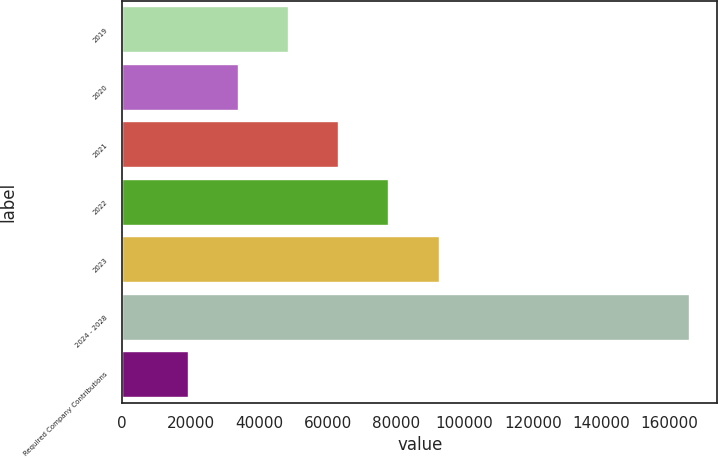<chart> <loc_0><loc_0><loc_500><loc_500><bar_chart><fcel>2019<fcel>2020<fcel>2021<fcel>2022<fcel>2023<fcel>2024 - 2028<fcel>Required Company Contributions<nl><fcel>48542.6<fcel>33900.3<fcel>63184.9<fcel>77827.2<fcel>92469.5<fcel>165681<fcel>19258<nl></chart> 